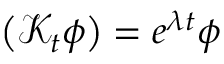Convert formula to latex. <formula><loc_0><loc_0><loc_500><loc_500>\left ( \mathcal { K } _ { t } \phi \right ) = e ^ { \lambda t } \phi</formula> 